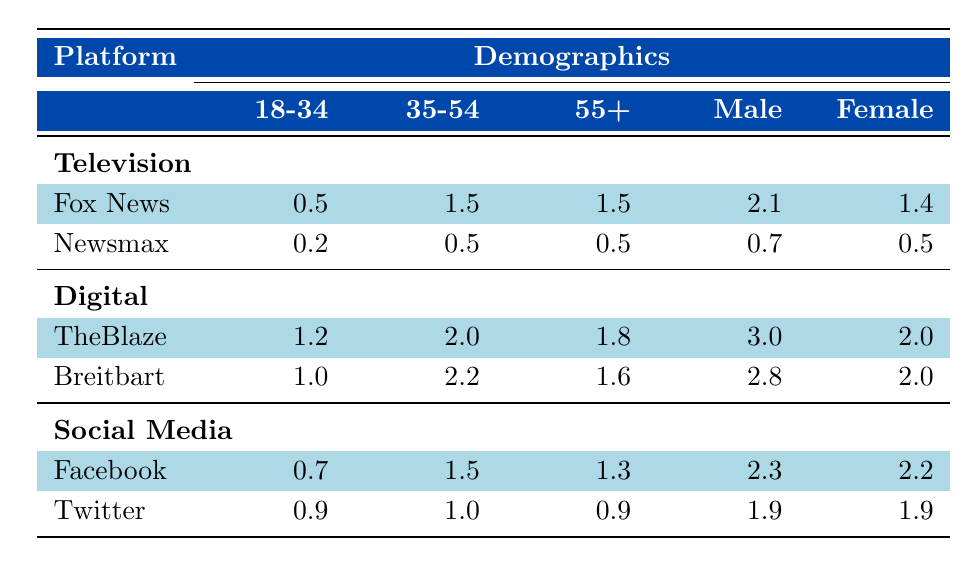What is the total viewership for Fox News? According to the table, the total viewers for Fox News is directly listed under the Television platform as 3.5 million.
Answer: 3.5 million Which demographic category has the highest total viewers for TheBlaze? In the demographics of TheBlaze, the "Male" category has the highest value at 3.0 million viewers compared to the other demographic segments (18-34, 35-54, 55+, and Female).
Answer: Male What is the combined viewership of Newsmax for age groups 18-34 and 35-54? To find this, we sum the viewers for Newsmax: 0.2 million (18-34) + 0.5 million (35-54) = 0.7 million total viewers in those age groups.
Answer: 0.7 million Is the engagement rate on Facebook higher than on Twitter? The engagement rate for Facebook is 4.5, while for Twitter it is 3.8. Since 4.5 is greater than 3.8, the statement is true.
Answer: Yes What percentage of total viewers for Fox News are male? The total viewers for Fox News is 3.5 million, and males account for 2.1 million of that. To find the percentage, divide 2.1 by 3.5 and multiply by 100, which equals approximately 60%.
Answer: 60% What is the average viewer count for the 35-54 age group across all television networks listed? The viewer counts for the 35-54 age group are: Fox News (1.5) and Newsmax (0.5). Adding these gives 1.5 + 0.5 = 2.0, and dividing by 2 (since there are 2 data points) gives an average of 1.0 million viewers.
Answer: 1.0 million How many more monthly visitors does TheBlaze have compared to Breitbart? TheBlaze has 5.0 million monthly visitors, and Breitbart has 4.8 million. The difference is 5.0 - 4.8 = 0.2 million monthly visitors more for TheBlaze.
Answer: 0.2 million For which region do Fox News viewers have the lowest count? The regions for Fox News and their respective viewers are: South (1.5), Midwest (1.0), Northeast (0.7), and West (0.3). The West has the lowest count at 0.3 million viewers.
Answer: West What is the total male viewership for Breitbart across all age groups? The male viewership figures for Breitbart are: 2.8 million (18-34), 2.2 million (35-54), and 2.0 million (55+). Adding these gives 2.8 + 2.2 + 2.0 = 7.0 million total male viewers.
Answer: 7.0 million 